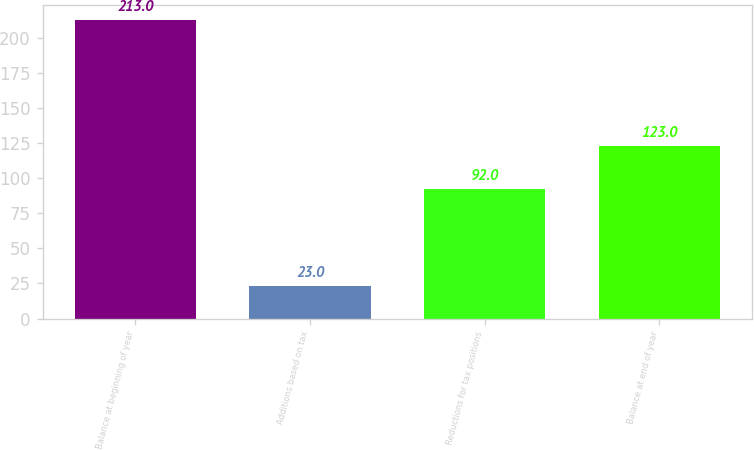<chart> <loc_0><loc_0><loc_500><loc_500><bar_chart><fcel>Balance at beginning of year<fcel>Additions based on tax<fcel>Reductions for tax positions<fcel>Balance at end of year<nl><fcel>213<fcel>23<fcel>92<fcel>123<nl></chart> 